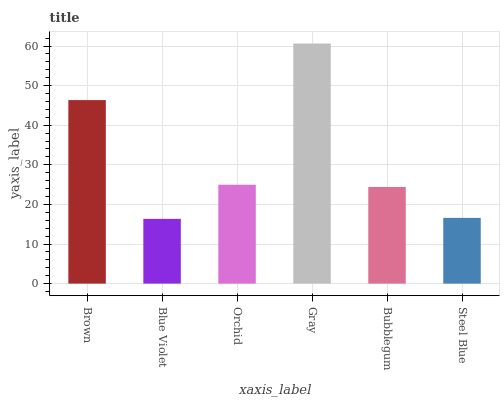Is Blue Violet the minimum?
Answer yes or no. Yes. Is Gray the maximum?
Answer yes or no. Yes. Is Orchid the minimum?
Answer yes or no. No. Is Orchid the maximum?
Answer yes or no. No. Is Orchid greater than Blue Violet?
Answer yes or no. Yes. Is Blue Violet less than Orchid?
Answer yes or no. Yes. Is Blue Violet greater than Orchid?
Answer yes or no. No. Is Orchid less than Blue Violet?
Answer yes or no. No. Is Orchid the high median?
Answer yes or no. Yes. Is Bubblegum the low median?
Answer yes or no. Yes. Is Steel Blue the high median?
Answer yes or no. No. Is Gray the low median?
Answer yes or no. No. 